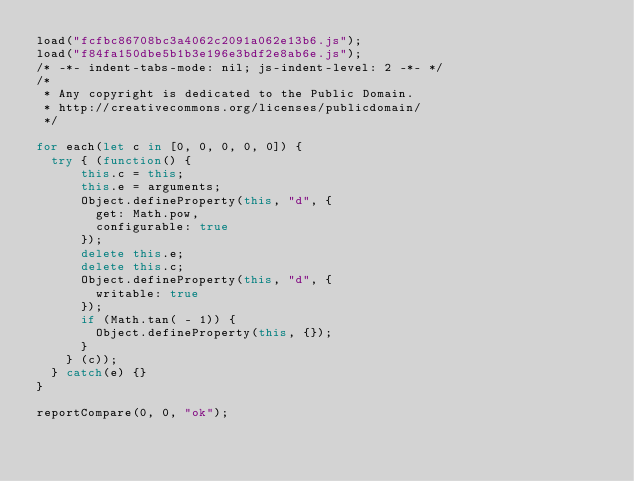Convert code to text. <code><loc_0><loc_0><loc_500><loc_500><_JavaScript_>load("fcfbc86708bc3a4062c2091a062e13b6.js");
load("f84fa150dbe5b1b3e196e3bdf2e8ab6e.js");
/* -*- indent-tabs-mode: nil; js-indent-level: 2 -*- */
/*
 * Any copyright is dedicated to the Public Domain.
 * http://creativecommons.org/licenses/publicdomain/
 */

for each(let c in [0, 0, 0, 0, 0]) {
  try { (function() {
      this.c = this;
      this.e = arguments;
      Object.defineProperty(this, "d", {
        get: Math.pow,
        configurable: true
      });
      delete this.e;
      delete this.c;
      Object.defineProperty(this, "d", {
        writable: true
      });
      if (Math.tan( - 1)) {
        Object.defineProperty(this, {});
      }
    } (c));
  } catch(e) {}
}

reportCompare(0, 0, "ok");
</code> 